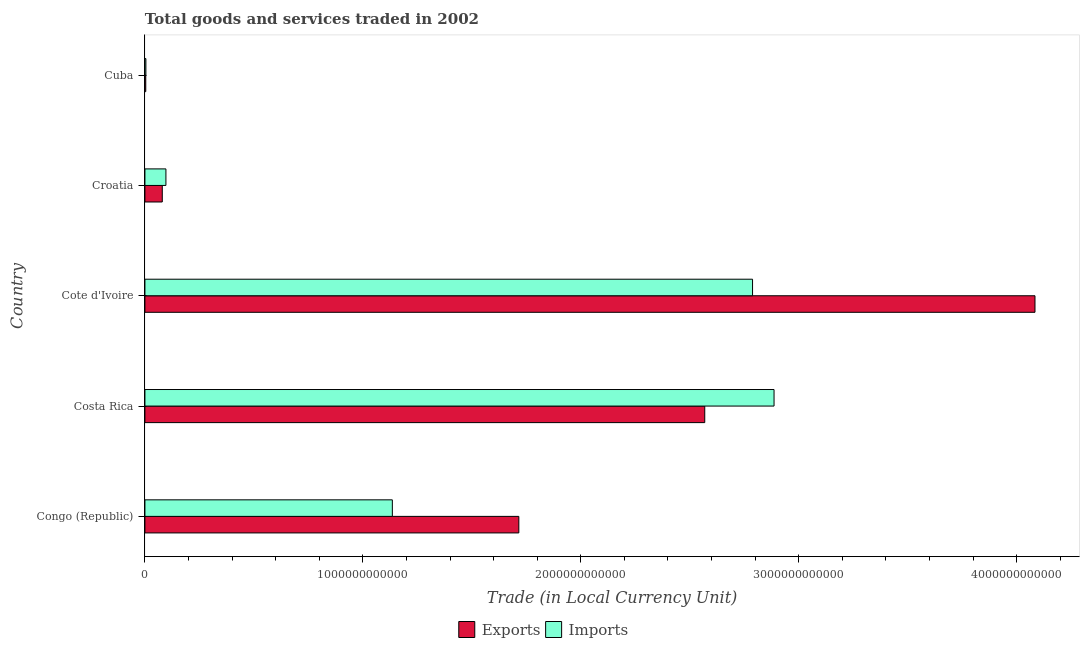How many different coloured bars are there?
Keep it short and to the point. 2. How many groups of bars are there?
Provide a short and direct response. 5. Are the number of bars per tick equal to the number of legend labels?
Make the answer very short. Yes. How many bars are there on the 5th tick from the top?
Your answer should be very brief. 2. What is the label of the 3rd group of bars from the top?
Make the answer very short. Cote d'Ivoire. What is the export of goods and services in Croatia?
Provide a succinct answer. 7.97e+1. Across all countries, what is the maximum export of goods and services?
Make the answer very short. 4.08e+12. Across all countries, what is the minimum export of goods and services?
Provide a succinct answer. 3.87e+09. In which country was the export of goods and services maximum?
Keep it short and to the point. Cote d'Ivoire. In which country was the imports of goods and services minimum?
Keep it short and to the point. Cuba. What is the total imports of goods and services in the graph?
Your answer should be very brief. 6.91e+12. What is the difference between the export of goods and services in Costa Rica and that in Croatia?
Ensure brevity in your answer.  2.49e+12. What is the difference between the imports of goods and services in Cote d'Ivoire and the export of goods and services in Cuba?
Your answer should be compact. 2.78e+12. What is the average export of goods and services per country?
Give a very brief answer. 1.69e+12. What is the difference between the imports of goods and services and export of goods and services in Cuba?
Provide a short and direct response. 5.63e+08. In how many countries, is the imports of goods and services greater than 2600000000000 LCU?
Offer a very short reply. 2. What is the ratio of the export of goods and services in Costa Rica to that in Cote d'Ivoire?
Your answer should be compact. 0.63. Is the export of goods and services in Costa Rica less than that in Croatia?
Your response must be concise. No. Is the difference between the imports of goods and services in Cote d'Ivoire and Cuba greater than the difference between the export of goods and services in Cote d'Ivoire and Cuba?
Your answer should be very brief. No. What is the difference between the highest and the second highest imports of goods and services?
Give a very brief answer. 9.87e+1. What is the difference between the highest and the lowest export of goods and services?
Your response must be concise. 4.08e+12. Is the sum of the export of goods and services in Congo (Republic) and Cuba greater than the maximum imports of goods and services across all countries?
Keep it short and to the point. No. What does the 1st bar from the top in Cuba represents?
Provide a succinct answer. Imports. What does the 2nd bar from the bottom in Cote d'Ivoire represents?
Provide a short and direct response. Imports. How many countries are there in the graph?
Provide a short and direct response. 5. What is the difference between two consecutive major ticks on the X-axis?
Offer a very short reply. 1.00e+12. Are the values on the major ticks of X-axis written in scientific E-notation?
Your answer should be compact. No. Does the graph contain any zero values?
Ensure brevity in your answer.  No. How many legend labels are there?
Provide a short and direct response. 2. How are the legend labels stacked?
Give a very brief answer. Horizontal. What is the title of the graph?
Offer a very short reply. Total goods and services traded in 2002. Does "Fraud firms" appear as one of the legend labels in the graph?
Offer a very short reply. No. What is the label or title of the X-axis?
Give a very brief answer. Trade (in Local Currency Unit). What is the Trade (in Local Currency Unit) of Exports in Congo (Republic)?
Provide a short and direct response. 1.72e+12. What is the Trade (in Local Currency Unit) of Imports in Congo (Republic)?
Your response must be concise. 1.14e+12. What is the Trade (in Local Currency Unit) of Exports in Costa Rica?
Your response must be concise. 2.57e+12. What is the Trade (in Local Currency Unit) in Imports in Costa Rica?
Give a very brief answer. 2.89e+12. What is the Trade (in Local Currency Unit) of Exports in Cote d'Ivoire?
Your response must be concise. 4.08e+12. What is the Trade (in Local Currency Unit) of Imports in Cote d'Ivoire?
Make the answer very short. 2.79e+12. What is the Trade (in Local Currency Unit) in Exports in Croatia?
Give a very brief answer. 7.97e+1. What is the Trade (in Local Currency Unit) in Imports in Croatia?
Offer a terse response. 9.64e+1. What is the Trade (in Local Currency Unit) of Exports in Cuba?
Keep it short and to the point. 3.87e+09. What is the Trade (in Local Currency Unit) of Imports in Cuba?
Your answer should be very brief. 4.43e+09. Across all countries, what is the maximum Trade (in Local Currency Unit) of Exports?
Provide a short and direct response. 4.08e+12. Across all countries, what is the maximum Trade (in Local Currency Unit) in Imports?
Offer a terse response. 2.89e+12. Across all countries, what is the minimum Trade (in Local Currency Unit) in Exports?
Provide a succinct answer. 3.87e+09. Across all countries, what is the minimum Trade (in Local Currency Unit) in Imports?
Your response must be concise. 4.43e+09. What is the total Trade (in Local Currency Unit) in Exports in the graph?
Ensure brevity in your answer.  8.45e+12. What is the total Trade (in Local Currency Unit) of Imports in the graph?
Your answer should be compact. 6.91e+12. What is the difference between the Trade (in Local Currency Unit) in Exports in Congo (Republic) and that in Costa Rica?
Ensure brevity in your answer.  -8.53e+11. What is the difference between the Trade (in Local Currency Unit) of Imports in Congo (Republic) and that in Costa Rica?
Give a very brief answer. -1.75e+12. What is the difference between the Trade (in Local Currency Unit) of Exports in Congo (Republic) and that in Cote d'Ivoire?
Provide a short and direct response. -2.37e+12. What is the difference between the Trade (in Local Currency Unit) of Imports in Congo (Republic) and that in Cote d'Ivoire?
Offer a terse response. -1.65e+12. What is the difference between the Trade (in Local Currency Unit) in Exports in Congo (Republic) and that in Croatia?
Offer a terse response. 1.64e+12. What is the difference between the Trade (in Local Currency Unit) in Imports in Congo (Republic) and that in Croatia?
Your response must be concise. 1.04e+12. What is the difference between the Trade (in Local Currency Unit) of Exports in Congo (Republic) and that in Cuba?
Offer a terse response. 1.71e+12. What is the difference between the Trade (in Local Currency Unit) in Imports in Congo (Republic) and that in Cuba?
Offer a terse response. 1.13e+12. What is the difference between the Trade (in Local Currency Unit) in Exports in Costa Rica and that in Cote d'Ivoire?
Offer a very short reply. -1.52e+12. What is the difference between the Trade (in Local Currency Unit) in Imports in Costa Rica and that in Cote d'Ivoire?
Your response must be concise. 9.87e+1. What is the difference between the Trade (in Local Currency Unit) of Exports in Costa Rica and that in Croatia?
Your answer should be compact. 2.49e+12. What is the difference between the Trade (in Local Currency Unit) of Imports in Costa Rica and that in Croatia?
Your response must be concise. 2.79e+12. What is the difference between the Trade (in Local Currency Unit) of Exports in Costa Rica and that in Cuba?
Your answer should be compact. 2.57e+12. What is the difference between the Trade (in Local Currency Unit) in Imports in Costa Rica and that in Cuba?
Your answer should be compact. 2.88e+12. What is the difference between the Trade (in Local Currency Unit) in Exports in Cote d'Ivoire and that in Croatia?
Your answer should be very brief. 4.00e+12. What is the difference between the Trade (in Local Currency Unit) in Imports in Cote d'Ivoire and that in Croatia?
Your response must be concise. 2.69e+12. What is the difference between the Trade (in Local Currency Unit) in Exports in Cote d'Ivoire and that in Cuba?
Offer a terse response. 4.08e+12. What is the difference between the Trade (in Local Currency Unit) in Imports in Cote d'Ivoire and that in Cuba?
Keep it short and to the point. 2.78e+12. What is the difference between the Trade (in Local Currency Unit) in Exports in Croatia and that in Cuba?
Offer a terse response. 7.58e+1. What is the difference between the Trade (in Local Currency Unit) in Imports in Croatia and that in Cuba?
Offer a very short reply. 9.19e+1. What is the difference between the Trade (in Local Currency Unit) in Exports in Congo (Republic) and the Trade (in Local Currency Unit) in Imports in Costa Rica?
Offer a very short reply. -1.17e+12. What is the difference between the Trade (in Local Currency Unit) in Exports in Congo (Republic) and the Trade (in Local Currency Unit) in Imports in Cote d'Ivoire?
Ensure brevity in your answer.  -1.07e+12. What is the difference between the Trade (in Local Currency Unit) in Exports in Congo (Republic) and the Trade (in Local Currency Unit) in Imports in Croatia?
Ensure brevity in your answer.  1.62e+12. What is the difference between the Trade (in Local Currency Unit) in Exports in Congo (Republic) and the Trade (in Local Currency Unit) in Imports in Cuba?
Your answer should be very brief. 1.71e+12. What is the difference between the Trade (in Local Currency Unit) of Exports in Costa Rica and the Trade (in Local Currency Unit) of Imports in Cote d'Ivoire?
Keep it short and to the point. -2.19e+11. What is the difference between the Trade (in Local Currency Unit) in Exports in Costa Rica and the Trade (in Local Currency Unit) in Imports in Croatia?
Give a very brief answer. 2.47e+12. What is the difference between the Trade (in Local Currency Unit) of Exports in Costa Rica and the Trade (in Local Currency Unit) of Imports in Cuba?
Your response must be concise. 2.56e+12. What is the difference between the Trade (in Local Currency Unit) in Exports in Cote d'Ivoire and the Trade (in Local Currency Unit) in Imports in Croatia?
Offer a terse response. 3.99e+12. What is the difference between the Trade (in Local Currency Unit) of Exports in Cote d'Ivoire and the Trade (in Local Currency Unit) of Imports in Cuba?
Make the answer very short. 4.08e+12. What is the difference between the Trade (in Local Currency Unit) in Exports in Croatia and the Trade (in Local Currency Unit) in Imports in Cuba?
Ensure brevity in your answer.  7.53e+1. What is the average Trade (in Local Currency Unit) of Exports per country?
Offer a terse response. 1.69e+12. What is the average Trade (in Local Currency Unit) in Imports per country?
Offer a very short reply. 1.38e+12. What is the difference between the Trade (in Local Currency Unit) of Exports and Trade (in Local Currency Unit) of Imports in Congo (Republic)?
Provide a succinct answer. 5.80e+11. What is the difference between the Trade (in Local Currency Unit) in Exports and Trade (in Local Currency Unit) in Imports in Costa Rica?
Keep it short and to the point. -3.18e+11. What is the difference between the Trade (in Local Currency Unit) of Exports and Trade (in Local Currency Unit) of Imports in Cote d'Ivoire?
Offer a terse response. 1.30e+12. What is the difference between the Trade (in Local Currency Unit) in Exports and Trade (in Local Currency Unit) in Imports in Croatia?
Offer a very short reply. -1.67e+1. What is the difference between the Trade (in Local Currency Unit) in Exports and Trade (in Local Currency Unit) in Imports in Cuba?
Your answer should be very brief. -5.63e+08. What is the ratio of the Trade (in Local Currency Unit) in Exports in Congo (Republic) to that in Costa Rica?
Provide a short and direct response. 0.67. What is the ratio of the Trade (in Local Currency Unit) in Imports in Congo (Republic) to that in Costa Rica?
Give a very brief answer. 0.39. What is the ratio of the Trade (in Local Currency Unit) in Exports in Congo (Republic) to that in Cote d'Ivoire?
Offer a very short reply. 0.42. What is the ratio of the Trade (in Local Currency Unit) of Imports in Congo (Republic) to that in Cote d'Ivoire?
Your answer should be compact. 0.41. What is the ratio of the Trade (in Local Currency Unit) of Exports in Congo (Republic) to that in Croatia?
Give a very brief answer. 21.53. What is the ratio of the Trade (in Local Currency Unit) in Imports in Congo (Republic) to that in Croatia?
Offer a terse response. 11.78. What is the ratio of the Trade (in Local Currency Unit) in Exports in Congo (Republic) to that in Cuba?
Provide a short and direct response. 443.14. What is the ratio of the Trade (in Local Currency Unit) in Imports in Congo (Republic) to that in Cuba?
Give a very brief answer. 256.02. What is the ratio of the Trade (in Local Currency Unit) in Exports in Costa Rica to that in Cote d'Ivoire?
Your response must be concise. 0.63. What is the ratio of the Trade (in Local Currency Unit) of Imports in Costa Rica to that in Cote d'Ivoire?
Provide a short and direct response. 1.04. What is the ratio of the Trade (in Local Currency Unit) in Exports in Costa Rica to that in Croatia?
Your answer should be very brief. 32.23. What is the ratio of the Trade (in Local Currency Unit) of Imports in Costa Rica to that in Croatia?
Your answer should be compact. 29.96. What is the ratio of the Trade (in Local Currency Unit) of Exports in Costa Rica to that in Cuba?
Ensure brevity in your answer.  663.48. What is the ratio of the Trade (in Local Currency Unit) in Imports in Costa Rica to that in Cuba?
Ensure brevity in your answer.  651.01. What is the ratio of the Trade (in Local Currency Unit) in Exports in Cote d'Ivoire to that in Croatia?
Your answer should be compact. 51.24. What is the ratio of the Trade (in Local Currency Unit) of Imports in Cote d'Ivoire to that in Croatia?
Your answer should be compact. 28.93. What is the ratio of the Trade (in Local Currency Unit) in Exports in Cote d'Ivoire to that in Cuba?
Your answer should be very brief. 1054.87. What is the ratio of the Trade (in Local Currency Unit) in Imports in Cote d'Ivoire to that in Cuba?
Your answer should be very brief. 628.76. What is the ratio of the Trade (in Local Currency Unit) of Exports in Croatia to that in Cuba?
Offer a very short reply. 20.59. What is the ratio of the Trade (in Local Currency Unit) of Imports in Croatia to that in Cuba?
Provide a succinct answer. 21.73. What is the difference between the highest and the second highest Trade (in Local Currency Unit) in Exports?
Offer a very short reply. 1.52e+12. What is the difference between the highest and the second highest Trade (in Local Currency Unit) in Imports?
Make the answer very short. 9.87e+1. What is the difference between the highest and the lowest Trade (in Local Currency Unit) of Exports?
Ensure brevity in your answer.  4.08e+12. What is the difference between the highest and the lowest Trade (in Local Currency Unit) in Imports?
Keep it short and to the point. 2.88e+12. 